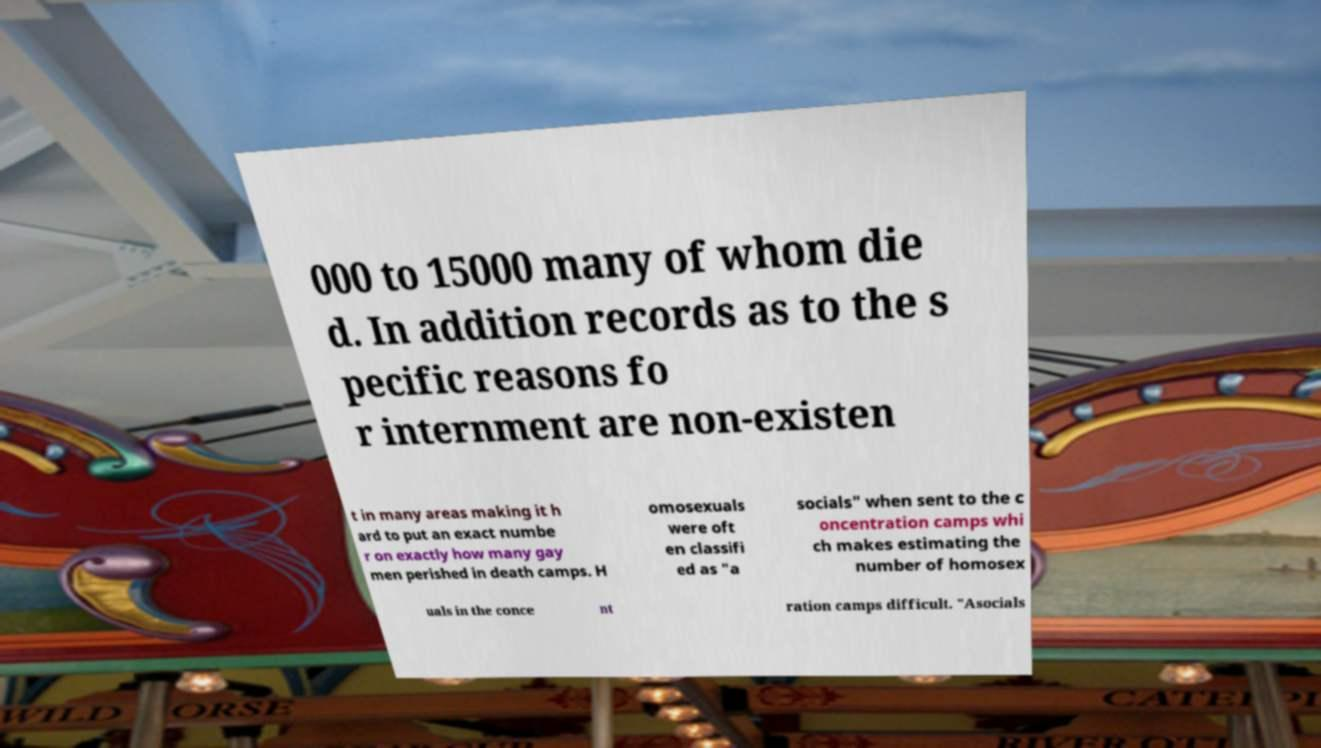There's text embedded in this image that I need extracted. Can you transcribe it verbatim? 000 to 15000 many of whom die d. In addition records as to the s pecific reasons fo r internment are non-existen t in many areas making it h ard to put an exact numbe r on exactly how many gay men perished in death camps. H omosexuals were oft en classifi ed as "a socials" when sent to the c oncentration camps whi ch makes estimating the number of homosex uals in the conce nt ration camps difficult. "Asocials 